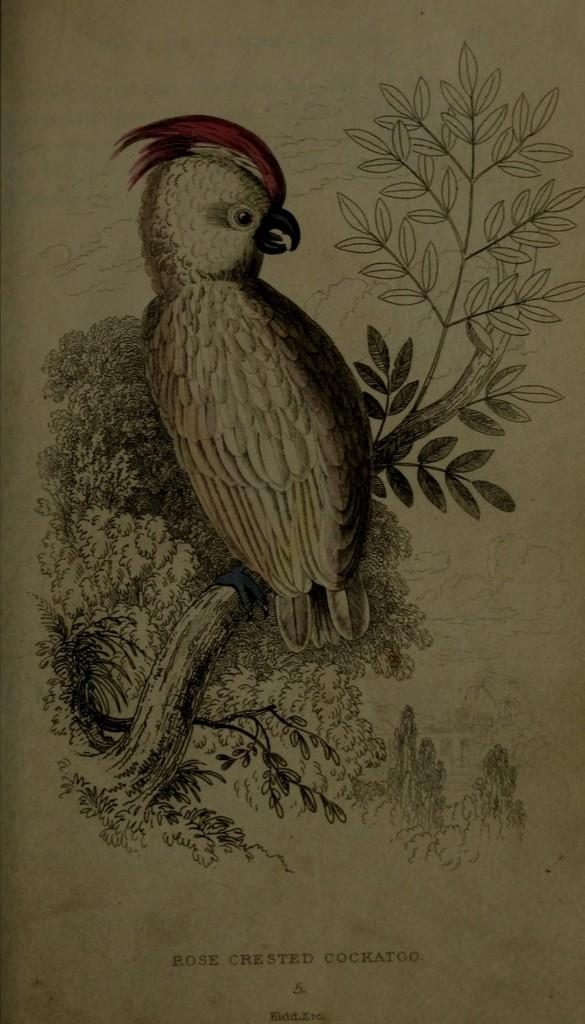What is the main subject of the image? There is a painting in the image. What is depicted in the painting? The painting depicts a bird. Where is the bird located in the painting? The bird is sitting on a branch of a tree in the painting. What type of pickle is the bird holding in the painting? There is no pickle present in the painting; the bird is sitting on a branch of a tree. 